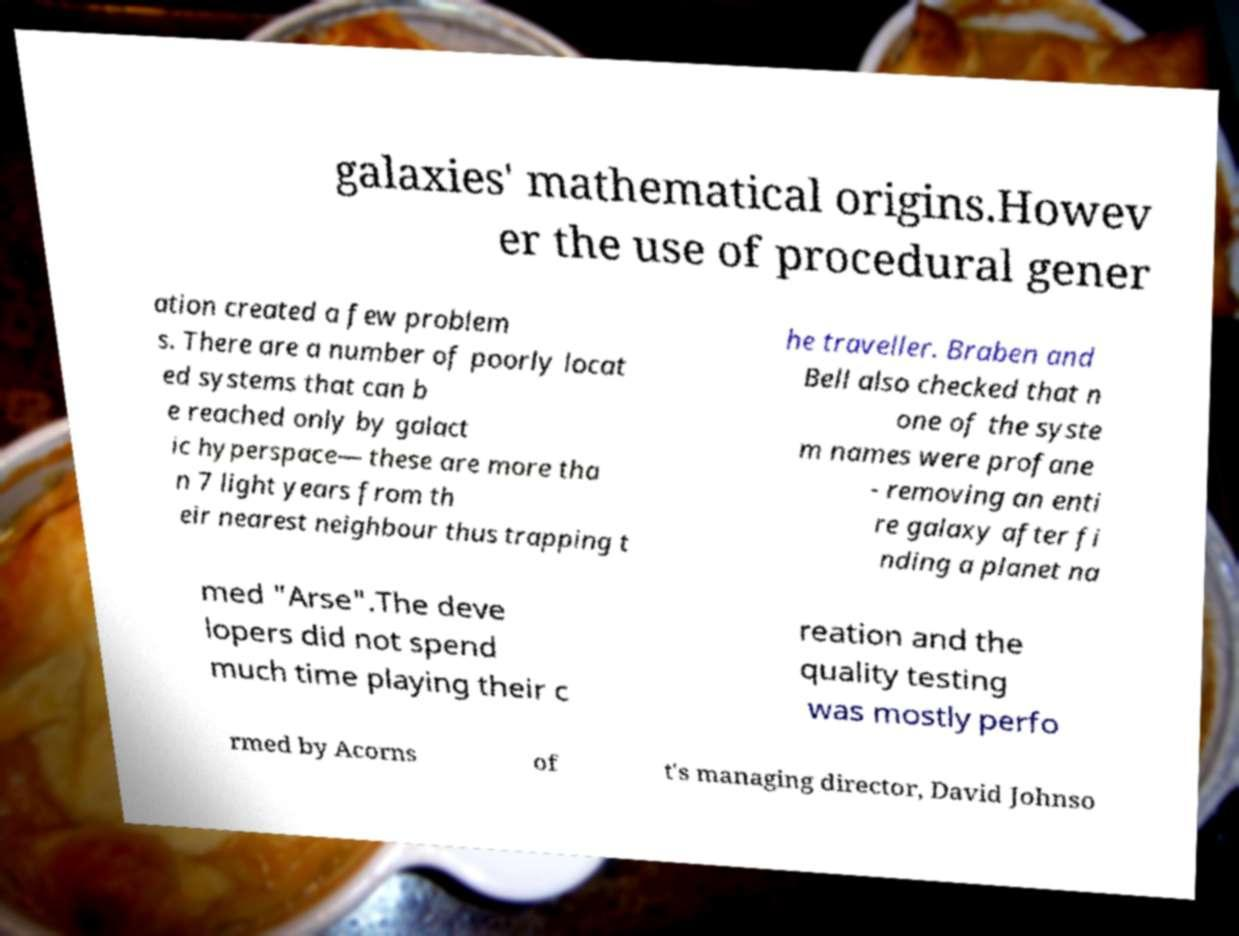Can you read and provide the text displayed in the image?This photo seems to have some interesting text. Can you extract and type it out for me? galaxies' mathematical origins.Howev er the use of procedural gener ation created a few problem s. There are a number of poorly locat ed systems that can b e reached only by galact ic hyperspace— these are more tha n 7 light years from th eir nearest neighbour thus trapping t he traveller. Braben and Bell also checked that n one of the syste m names were profane - removing an enti re galaxy after fi nding a planet na med "Arse".The deve lopers did not spend much time playing their c reation and the quality testing was mostly perfo rmed by Acorns of t's managing director, David Johnso 